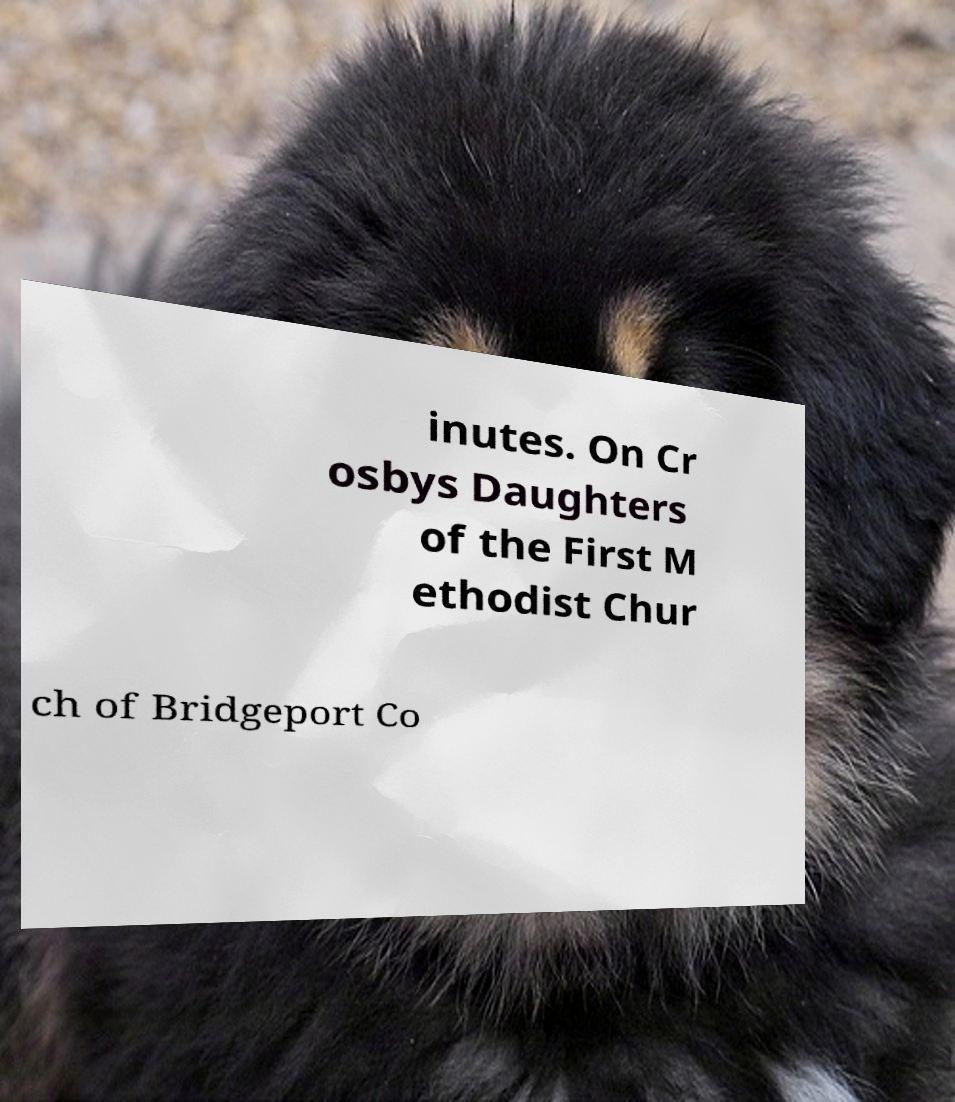I need the written content from this picture converted into text. Can you do that? inutes. On Cr osbys Daughters of the First M ethodist Chur ch of Bridgeport Co 